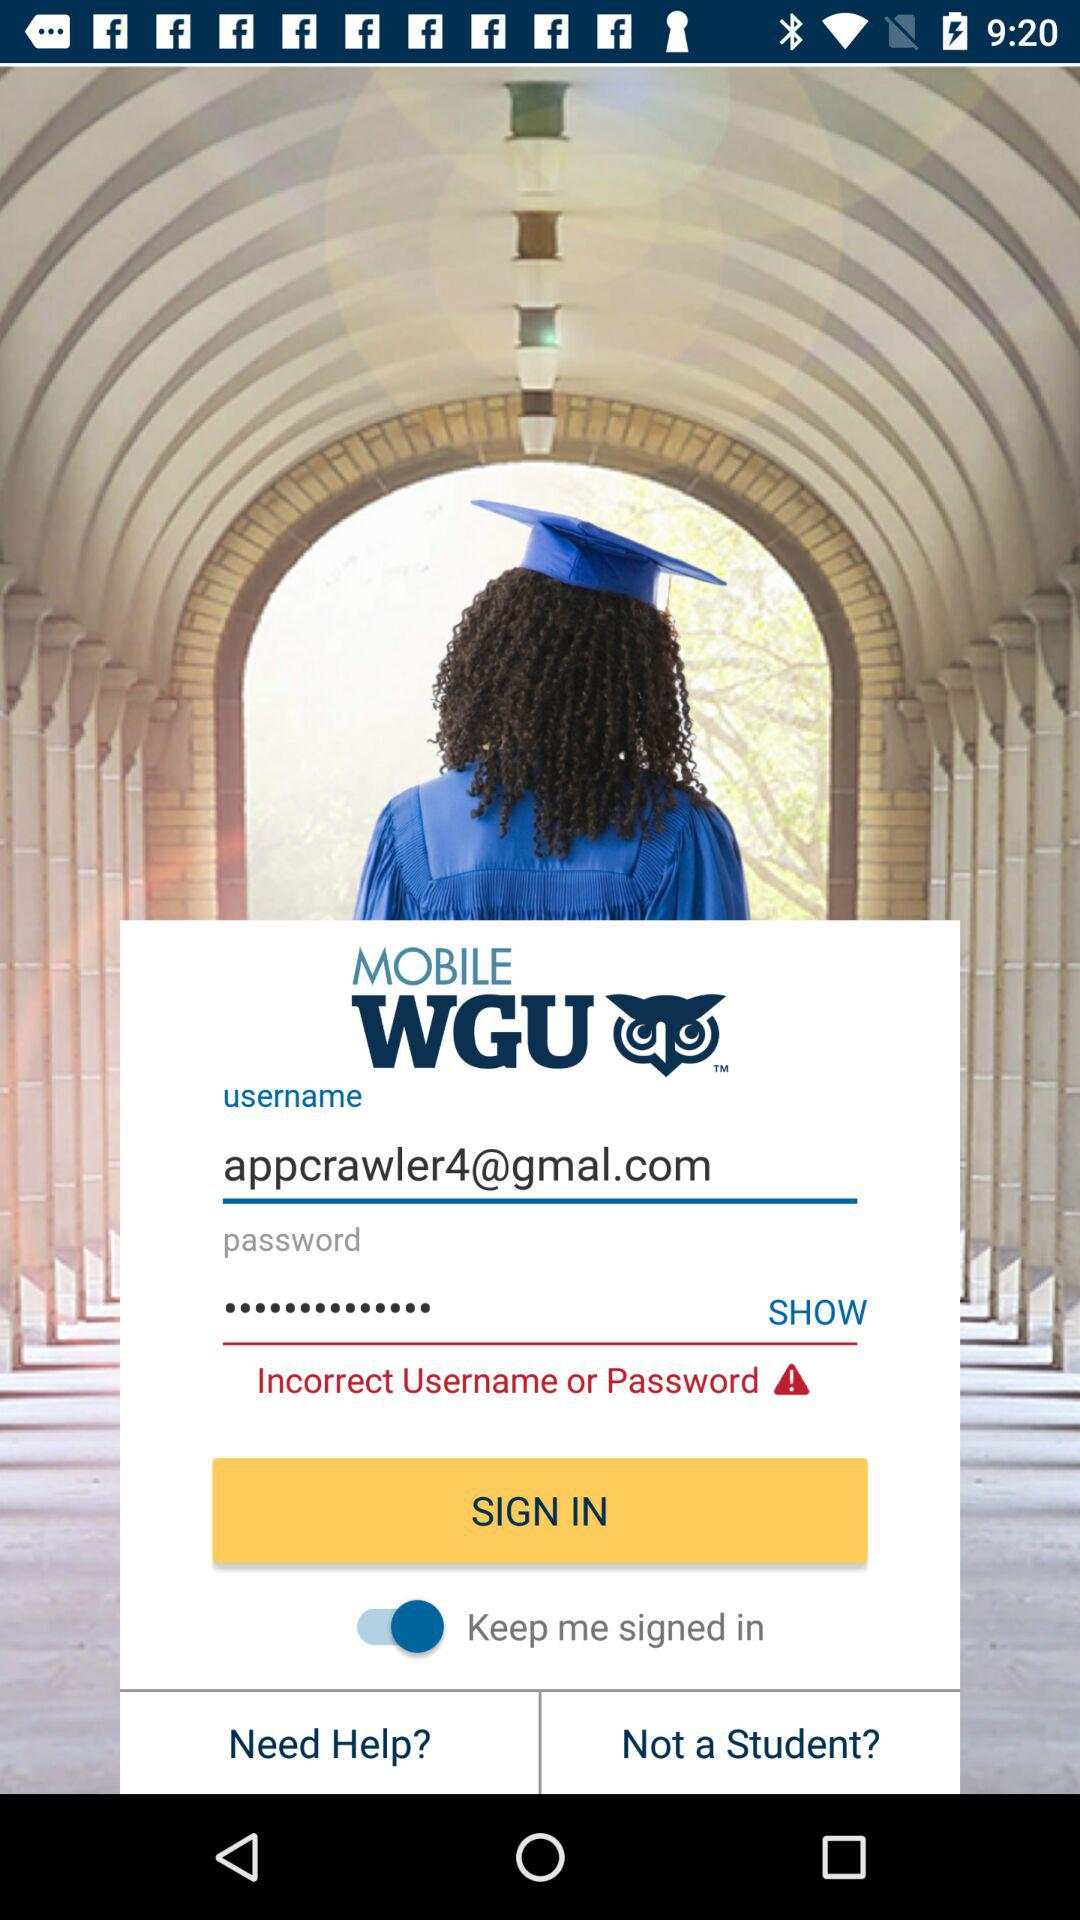How many text inputs are in the login screen?
Answer the question using a single word or phrase. 2 